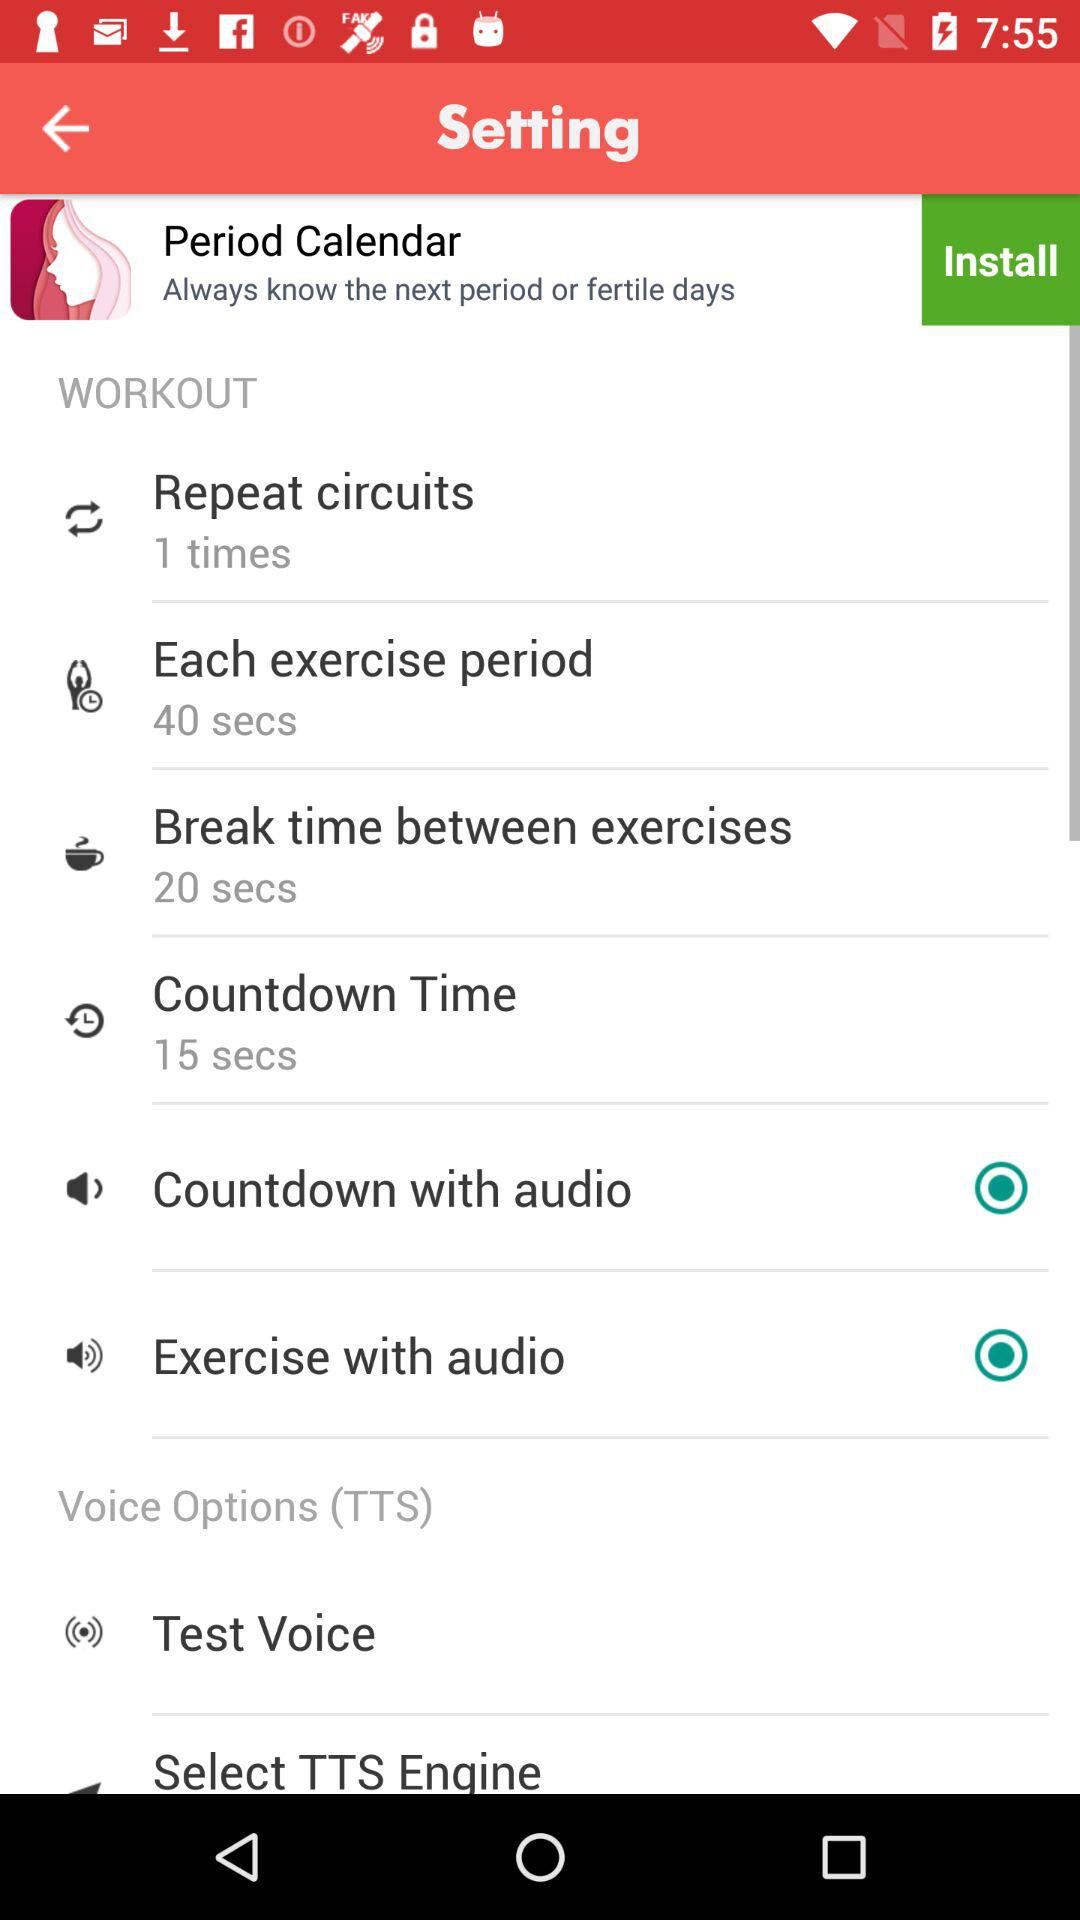What is the number of "Repeat circuits"? The number of "Repeat circuits" is 1. 